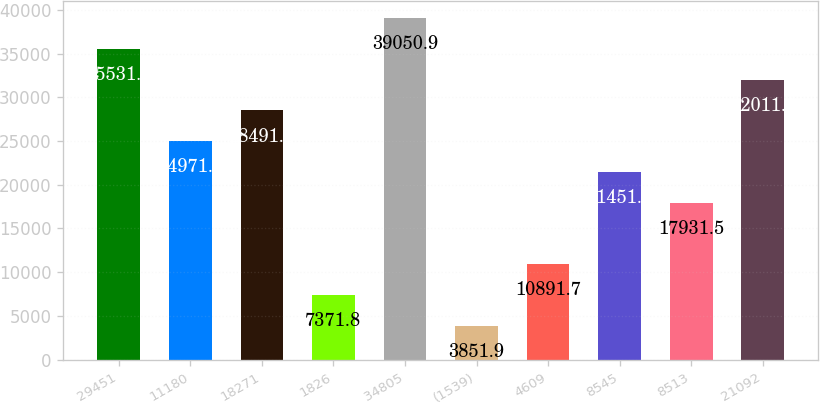Convert chart. <chart><loc_0><loc_0><loc_500><loc_500><bar_chart><fcel>29451<fcel>11180<fcel>18271<fcel>1826<fcel>34805<fcel>(1539)<fcel>4609<fcel>8545<fcel>8513<fcel>21092<nl><fcel>35531<fcel>24971.3<fcel>28491.2<fcel>7371.8<fcel>39050.9<fcel>3851.9<fcel>10891.7<fcel>21451.4<fcel>17931.5<fcel>32011.1<nl></chart> 